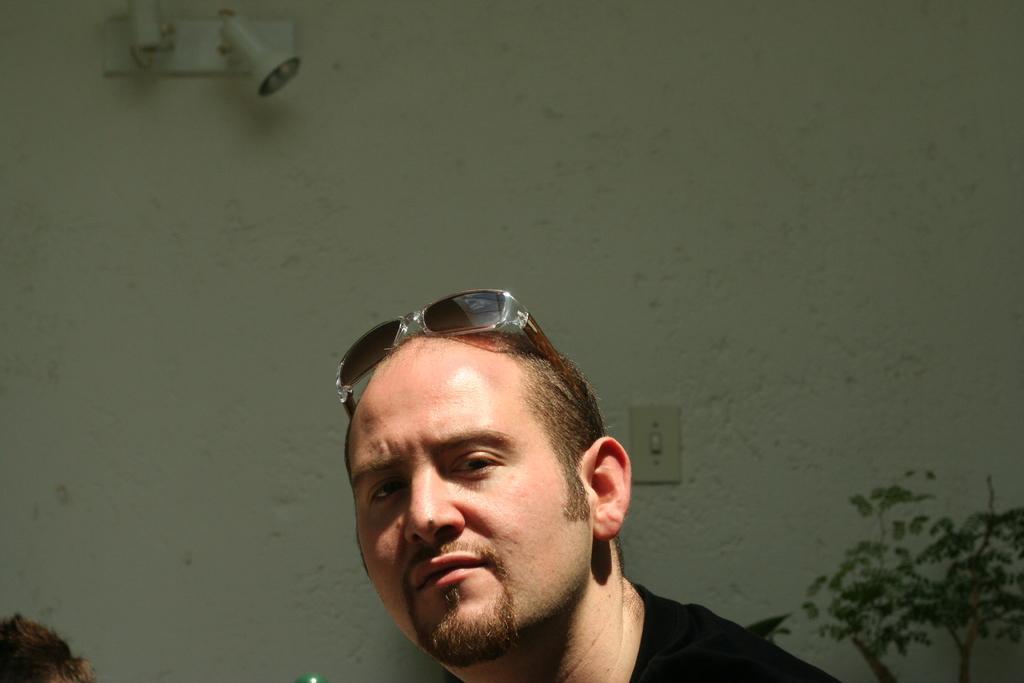Can you describe this image briefly? There is a man wore glasses. On the background we can see plant,wall and light. 